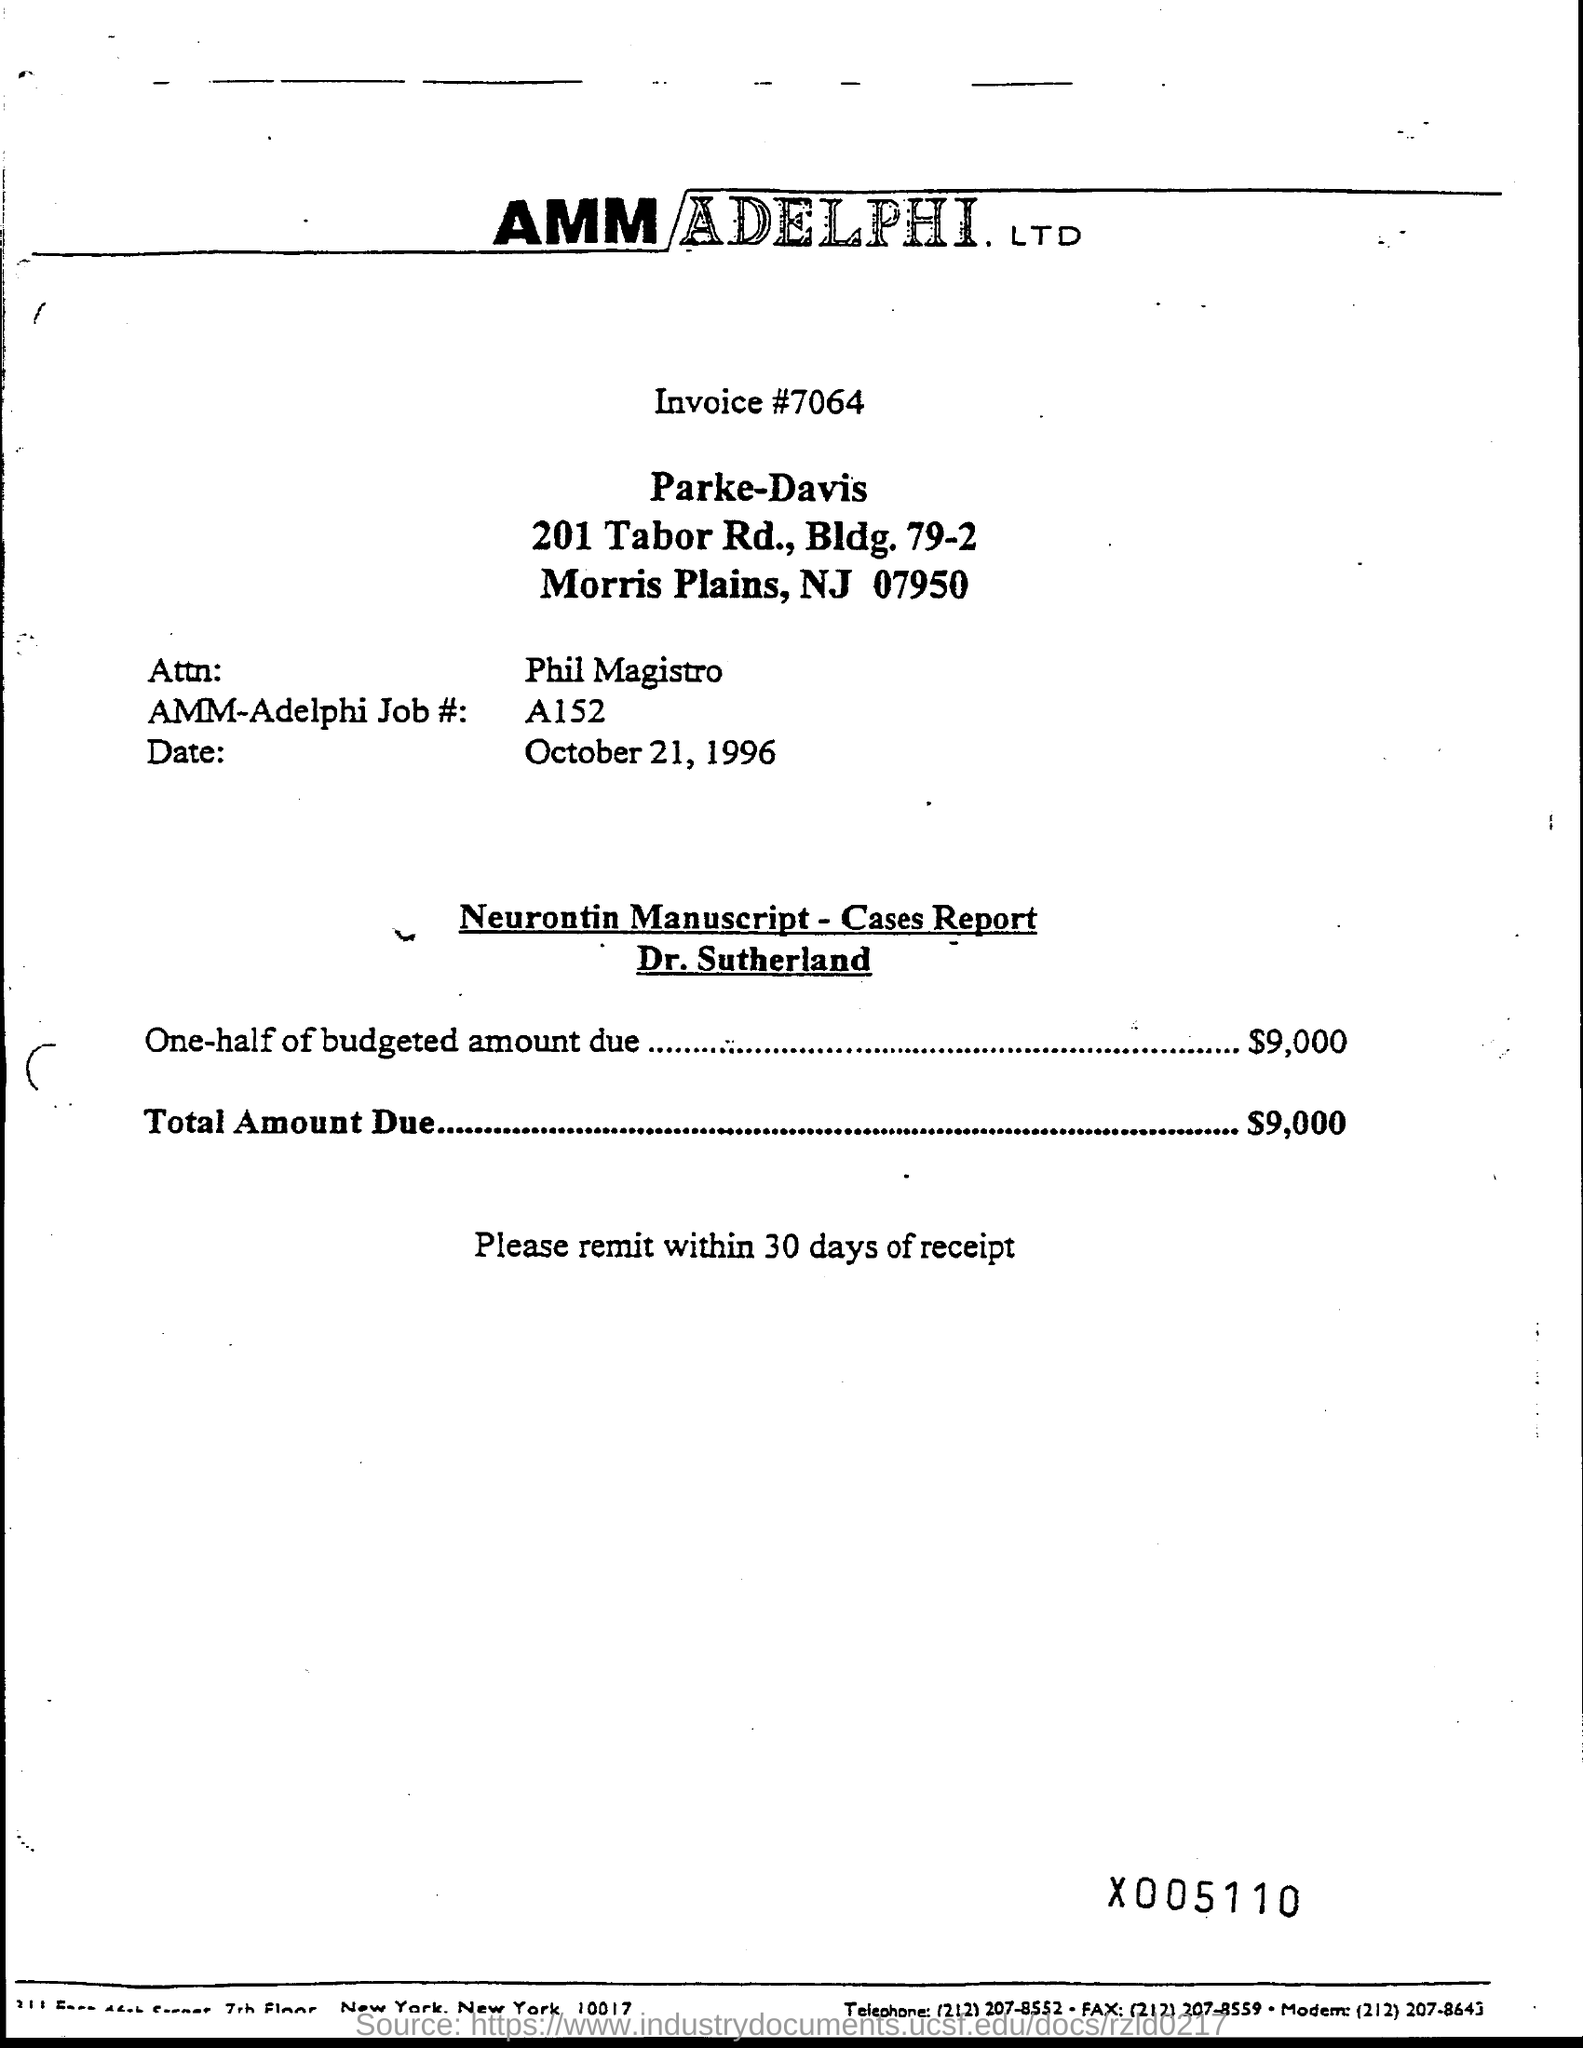Point out several critical features in this image. The name of Attn is PHIL MAGISTRO. The date mentioned in the document is October 21, 1996. The total amount due is $9,000. The invoice number is 7064. 